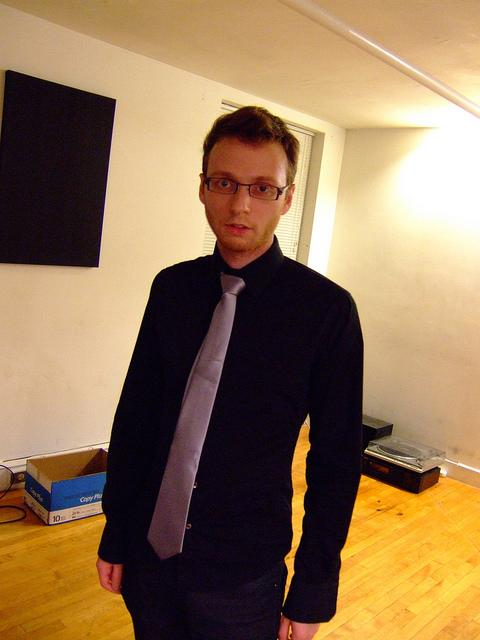What might explain the lack of furniture here? just moved 